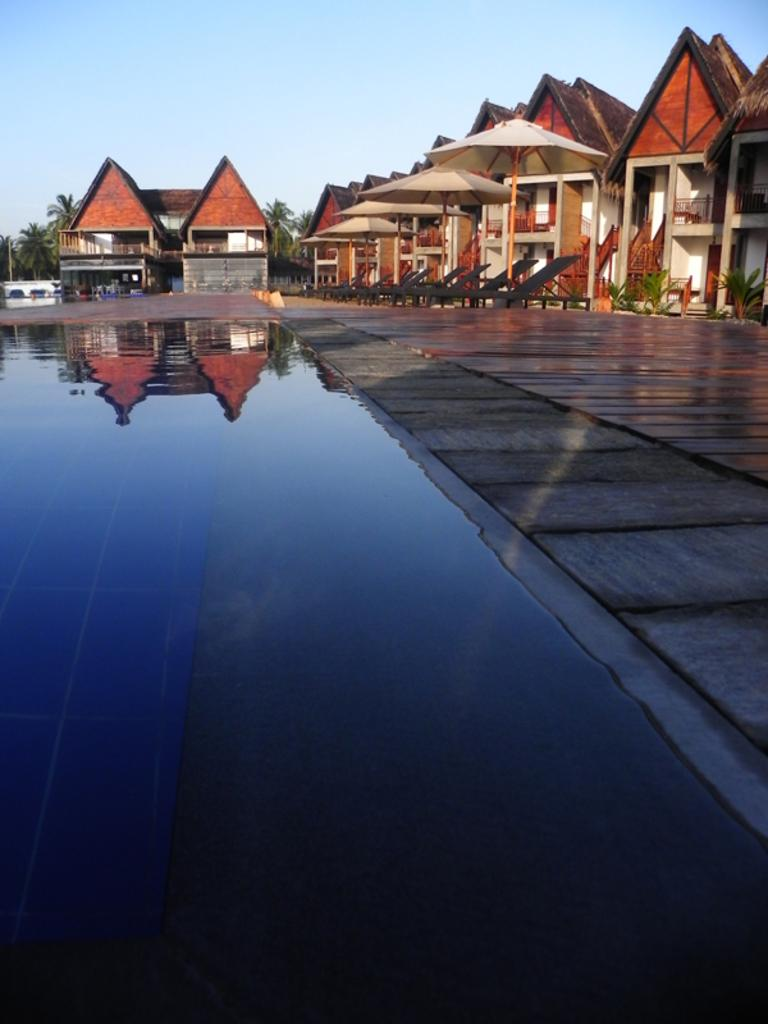What is located on the left side of the image? There is water on the left side of the image. What objects are present in the image for protection from the rain? There are umbrellas in the image. What type of structures can be seen in the image? There are houses in the image. What is visible at the top of the image? The sky is visible at the top of the image. What type of stamp can be seen on the houses in the image? There is no stamp present on the houses in the image. How many cattle are visible in the image? There are no cattle present in the image. 